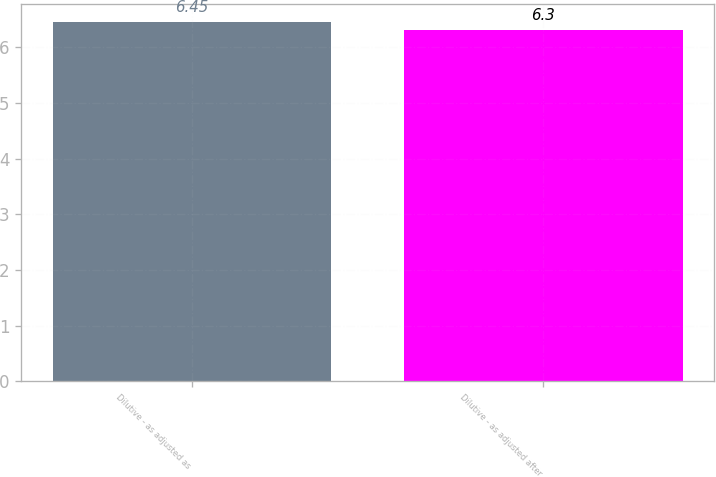<chart> <loc_0><loc_0><loc_500><loc_500><bar_chart><fcel>Dilutive - as adjusted as<fcel>Dilutive - as adjusted after<nl><fcel>6.45<fcel>6.3<nl></chart> 